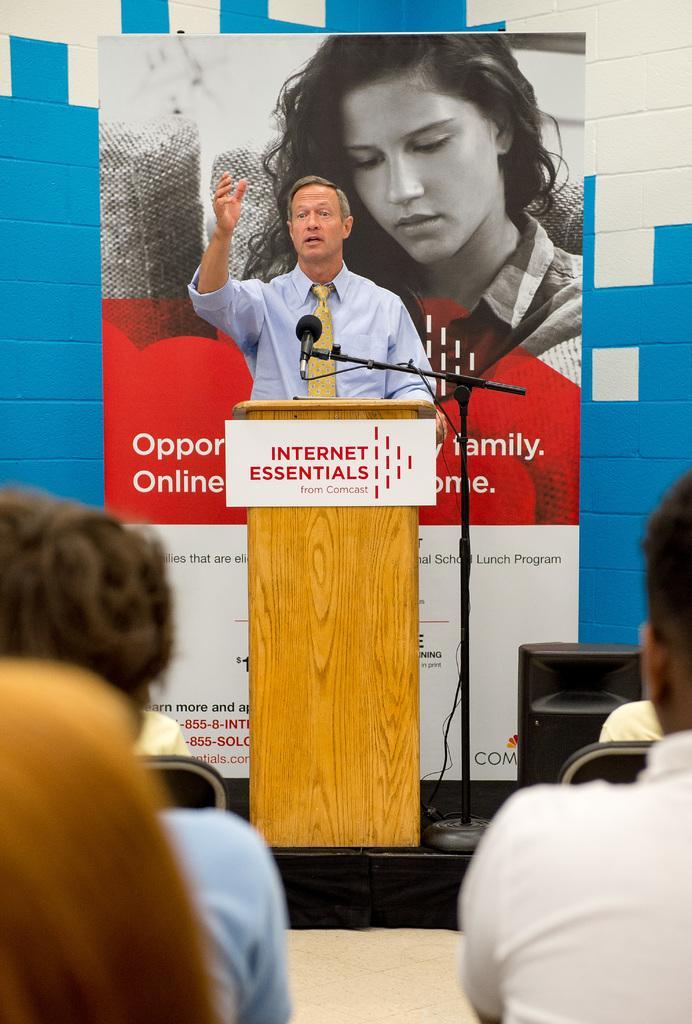Describe this image in one or two sentences. In the picture I can see a man standing in front of a wooden podium and he is speaking on a microphone. He is wearing a shirt and tie. I can see a few persons sitting on the chairs. In the background, I can see the hoarding. I can see the speaker on the right side. 